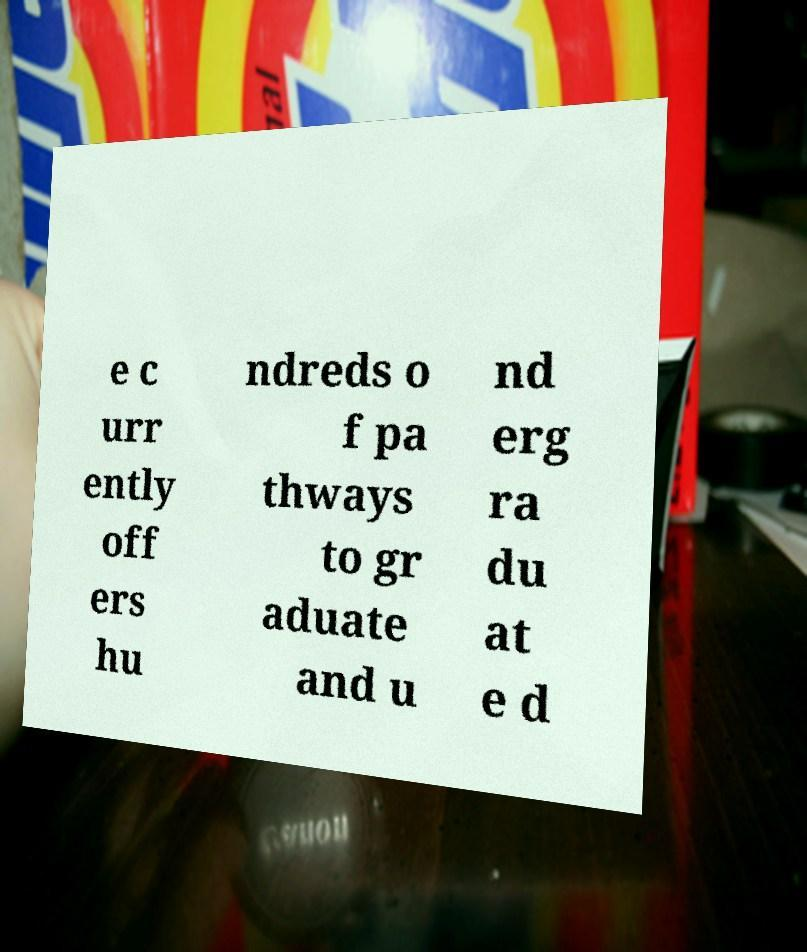Please identify and transcribe the text found in this image. e c urr ently off ers hu ndreds o f pa thways to gr aduate and u nd erg ra du at e d 